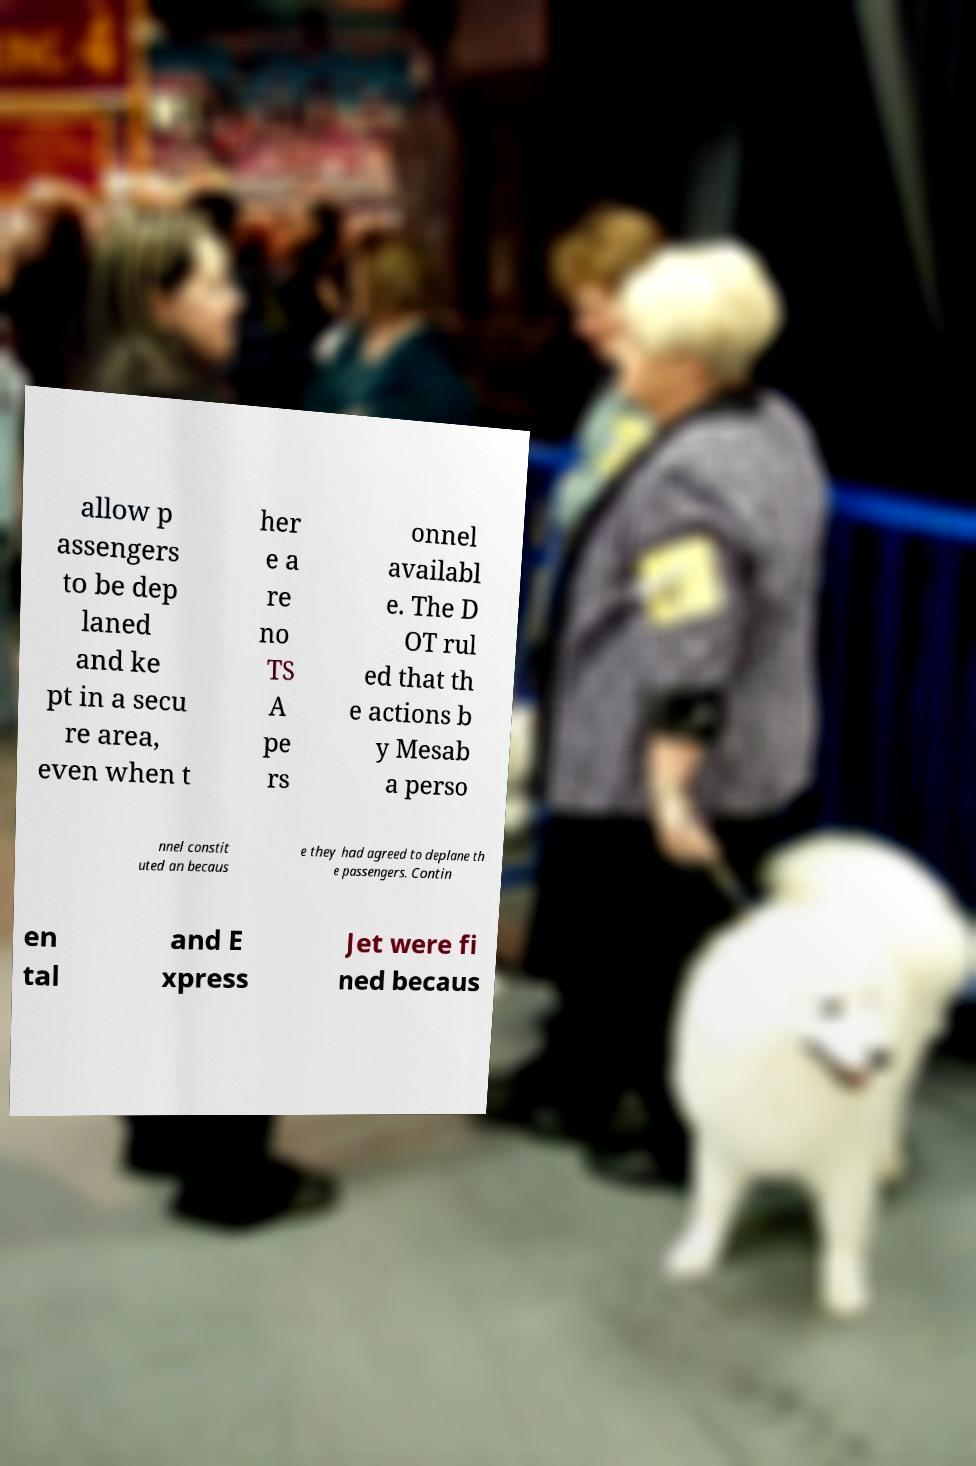What messages or text are displayed in this image? I need them in a readable, typed format. allow p assengers to be dep laned and ke pt in a secu re area, even when t her e a re no TS A pe rs onnel availabl e. The D OT rul ed that th e actions b y Mesab a perso nnel constit uted an becaus e they had agreed to deplane th e passengers. Contin en tal and E xpress Jet were fi ned becaus 